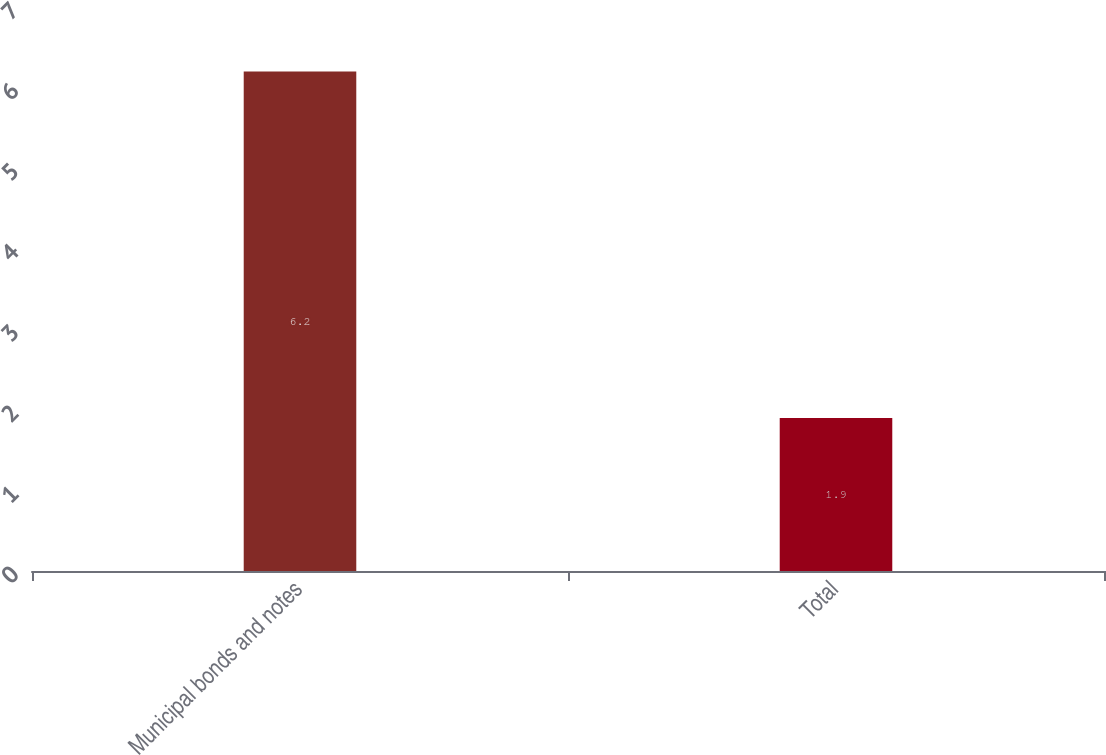<chart> <loc_0><loc_0><loc_500><loc_500><bar_chart><fcel>Municipal bonds and notes<fcel>Total<nl><fcel>6.2<fcel>1.9<nl></chart> 